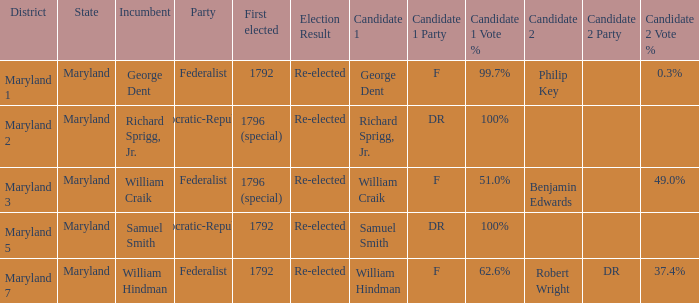What is the party when the incumbent is samuel smith? Democratic-Republican. 